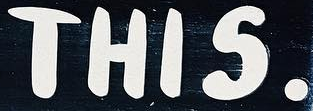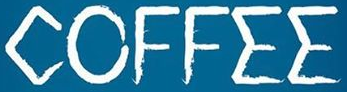What text is displayed in these images sequentially, separated by a semicolon? THIS.; COFFEE 